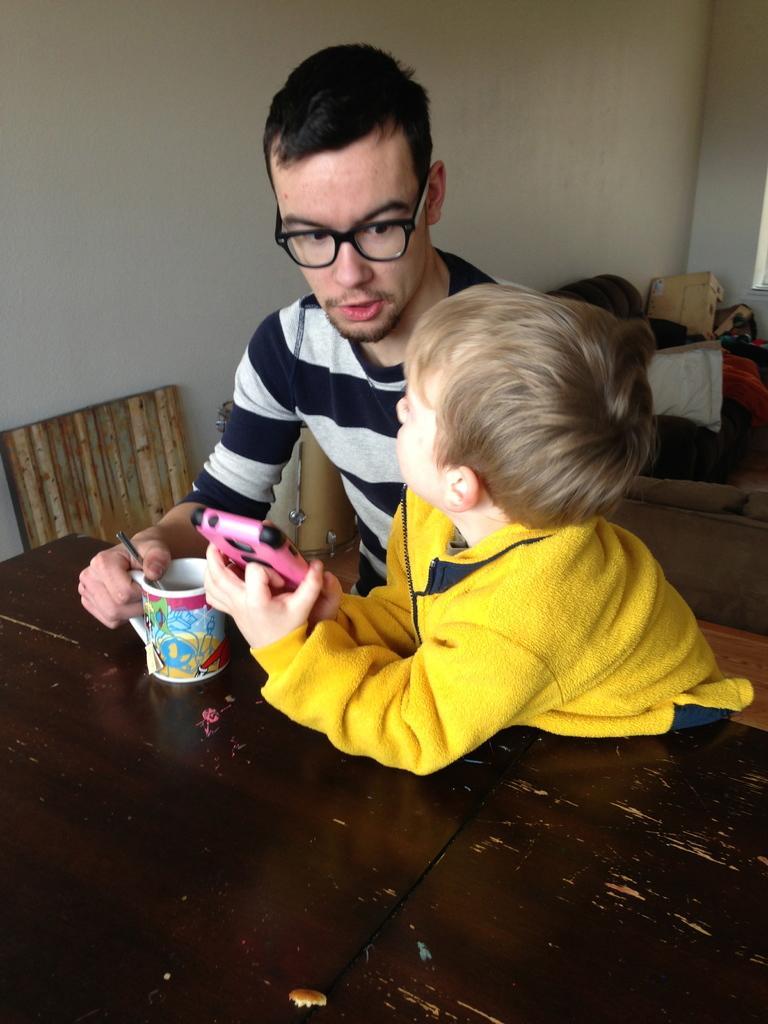In one or two sentences, can you explain what this image depicts? There is a person sitting on a chair, speaking and holding a cup which is on the table near a child who is in yellow color t-shirt, holding a mobile and keeping both elbows on the table. In the background, there is a chair near the wall and there are other objects. 